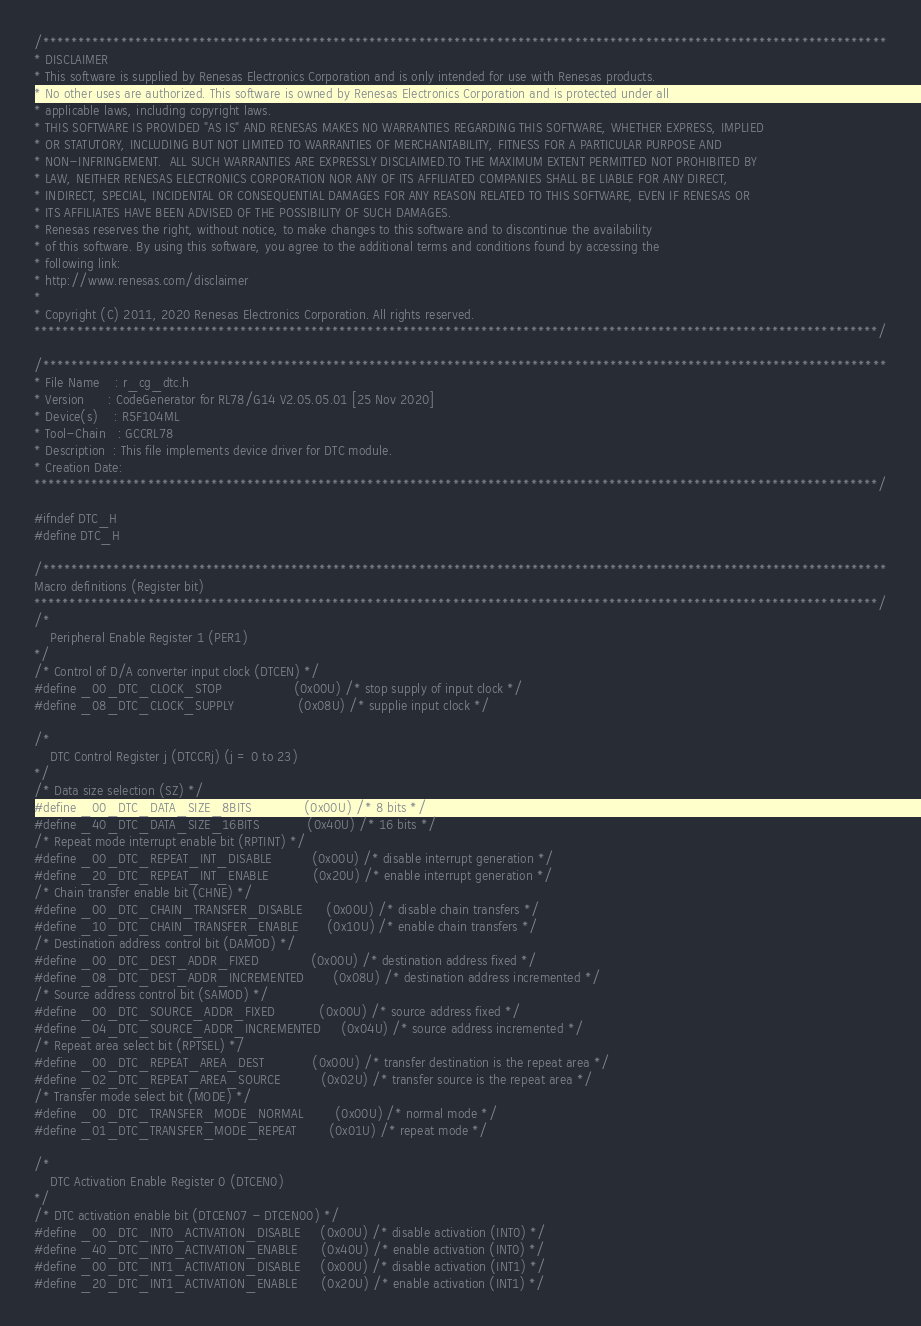<code> <loc_0><loc_0><loc_500><loc_500><_C_>/***********************************************************************************************************************
* DISCLAIMER
* This software is supplied by Renesas Electronics Corporation and is only intended for use with Renesas products.
* No other uses are authorized. This software is owned by Renesas Electronics Corporation and is protected under all
* applicable laws, including copyright laws. 
* THIS SOFTWARE IS PROVIDED "AS IS" AND RENESAS MAKES NO WARRANTIES REGARDING THIS SOFTWARE, WHETHER EXPRESS, IMPLIED
* OR STATUTORY, INCLUDING BUT NOT LIMITED TO WARRANTIES OF MERCHANTABILITY, FITNESS FOR A PARTICULAR PURPOSE AND
* NON-INFRINGEMENT.  ALL SUCH WARRANTIES ARE EXPRESSLY DISCLAIMED.TO THE MAXIMUM EXTENT PERMITTED NOT PROHIBITED BY
* LAW, NEITHER RENESAS ELECTRONICS CORPORATION NOR ANY OF ITS AFFILIATED COMPANIES SHALL BE LIABLE FOR ANY DIRECT,
* INDIRECT, SPECIAL, INCIDENTAL OR CONSEQUENTIAL DAMAGES FOR ANY REASON RELATED TO THIS SOFTWARE, EVEN IF RENESAS OR
* ITS AFFILIATES HAVE BEEN ADVISED OF THE POSSIBILITY OF SUCH DAMAGES.
* Renesas reserves the right, without notice, to make changes to this software and to discontinue the availability 
* of this software. By using this software, you agree to the additional terms and conditions found by accessing the 
* following link:
* http://www.renesas.com/disclaimer
*
* Copyright (C) 2011, 2020 Renesas Electronics Corporation. All rights reserved.
***********************************************************************************************************************/

/***********************************************************************************************************************
* File Name    : r_cg_dtc.h
* Version      : CodeGenerator for RL78/G14 V2.05.05.01 [25 Nov 2020]
* Device(s)    : R5F104ML
* Tool-Chain   : GCCRL78
* Description  : This file implements device driver for DTC module.
* Creation Date: 
***********************************************************************************************************************/

#ifndef DTC_H
#define DTC_H

/***********************************************************************************************************************
Macro definitions (Register bit)
***********************************************************************************************************************/
/* 
    Peripheral Enable Register 1 (PER1) 
*/
/* Control of D/A converter input clock (DTCEN) */
#define _00_DTC_CLOCK_STOP                  (0x00U) /* stop supply of input clock */
#define _08_DTC_CLOCK_SUPPLY                (0x08U) /* supplie input clock */

/*
    DTC Control Register j (DTCCRj) (j = 0 to 23)
*/
/* Data size selection (SZ) */
#define _00_DTC_DATA_SIZE_8BITS             (0x00U) /* 8 bits */
#define _40_DTC_DATA_SIZE_16BITS            (0x40U) /* 16 bits */
/* Repeat mode interrupt enable bit (RPTINT) */
#define _00_DTC_REPEAT_INT_DISABLE          (0x00U) /* disable interrupt generation */
#define _20_DTC_REPEAT_INT_ENABLE           (0x20U) /* enable interrupt generation */
/* Chain transfer enable bit (CHNE) */
#define _00_DTC_CHAIN_TRANSFER_DISABLE      (0x00U) /* disable chain transfers */
#define _10_DTC_CHAIN_TRANSFER_ENABLE       (0x10U) /* enable chain transfers */
/* Destination address control bit (DAMOD) */
#define _00_DTC_DEST_ADDR_FIXED             (0x00U) /* destination address fixed */
#define _08_DTC_DEST_ADDR_INCREMENTED       (0x08U) /* destination address incremented */
/* Source address control bit (SAMOD) */
#define _00_DTC_SOURCE_ADDR_FIXED           (0x00U) /* source address fixed */
#define _04_DTC_SOURCE_ADDR_INCREMENTED     (0x04U) /* source address incremented */
/* Repeat area select bit (RPTSEL) */
#define _00_DTC_REPEAT_AREA_DEST            (0x00U) /* transfer destination is the repeat area */
#define _02_DTC_REPEAT_AREA_SOURCE          (0x02U) /* transfer source is the repeat area */
/* Transfer mode select bit (MODE) */
#define _00_DTC_TRANSFER_MODE_NORMAL        (0x00U) /* normal mode */
#define _01_DTC_TRANSFER_MODE_REPEAT        (0x01U) /* repeat mode */

/*  
    DTC Activation Enable Register 0 (DTCEN0)
*/
/* DTC activation enable bit (DTCEN07 - DTCEN00) */
#define _00_DTC_INT0_ACTIVATION_DISABLE     (0x00U) /* disable activation (INT0) */
#define _40_DTC_INT0_ACTIVATION_ENABLE      (0x40U) /* enable activation (INT0) */
#define _00_DTC_INT1_ACTIVATION_DISABLE     (0x00U) /* disable activation (INT1) */
#define _20_DTC_INT1_ACTIVATION_ENABLE      (0x20U) /* enable activation (INT1) */</code> 